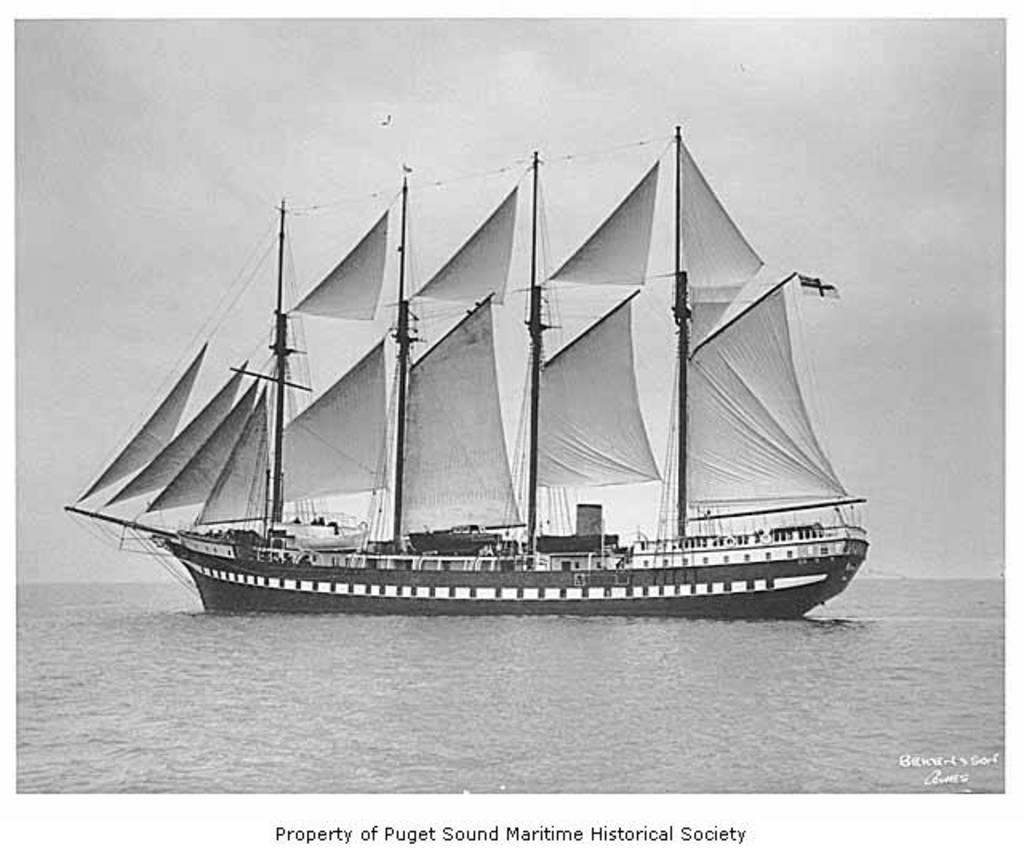What is the main subject of the image? There is a ship in the image. Where is the ship located? The ship is in the water. What is the color scheme of the image? The image is in black and white color. Can you see a squirrel climbing on the ship in the image? There is no squirrel present in the image, and therefore no such activity can be observed. 